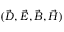<formula> <loc_0><loc_0><loc_500><loc_500>( \vec { D } , \vec { E } , \vec { B } , \vec { H } )</formula> 